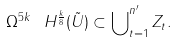Convert formula to latex. <formula><loc_0><loc_0><loc_500><loc_500>\Omega ^ { 5 k } \ H ^ { \frac { k } { 8 } } ( \tilde { U } ) \subset \bigcup \nolimits ^ { n ^ { \prime } } _ { t = 1 } Z _ { t } .</formula> 